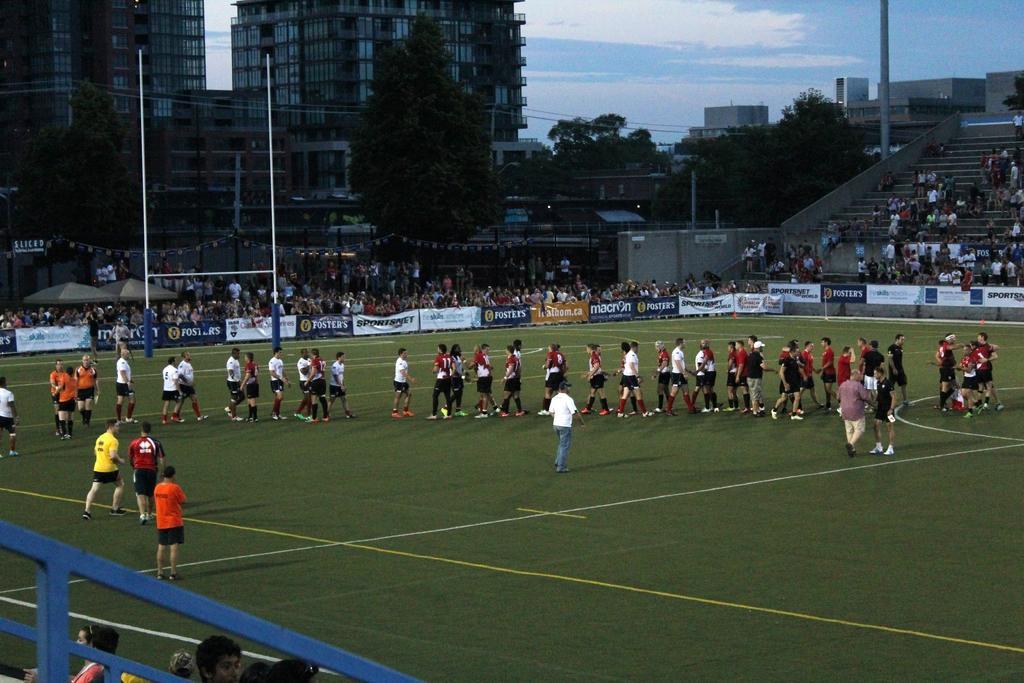Can you describe this image briefly? On the background of the picture we can see buildings and trees. At the top we can see a clear blue sky with clouds. These are the steps where audience can be seated. This is a playing ground, here all the players are standing. this is a hoarding. These are also audience. This is a ground. 